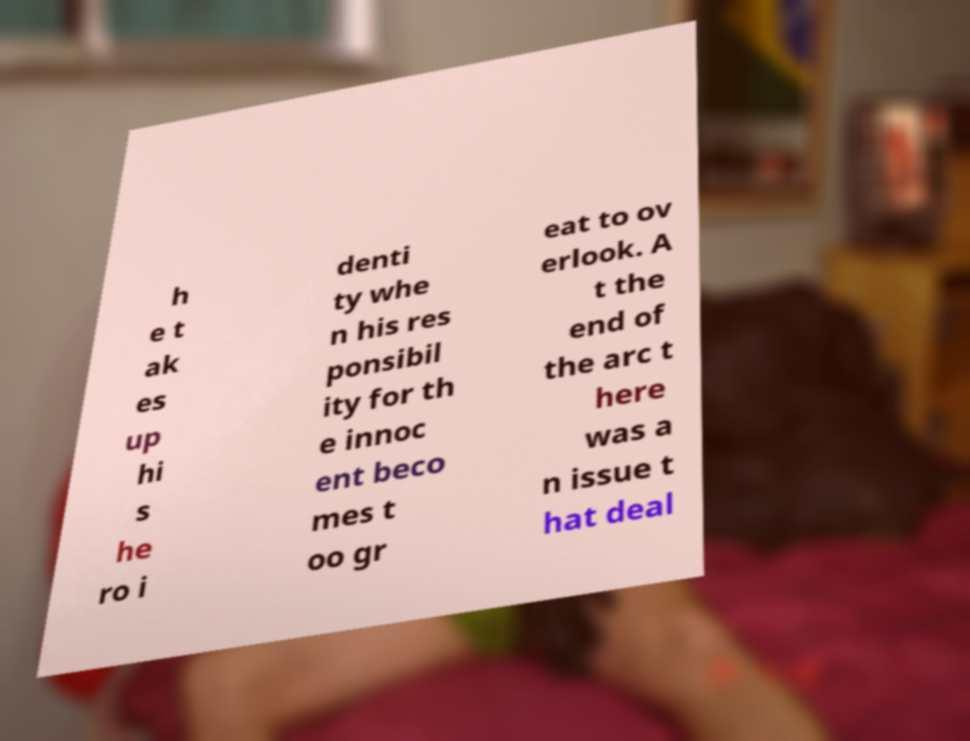Could you assist in decoding the text presented in this image and type it out clearly? h e t ak es up hi s he ro i denti ty whe n his res ponsibil ity for th e innoc ent beco mes t oo gr eat to ov erlook. A t the end of the arc t here was a n issue t hat deal 